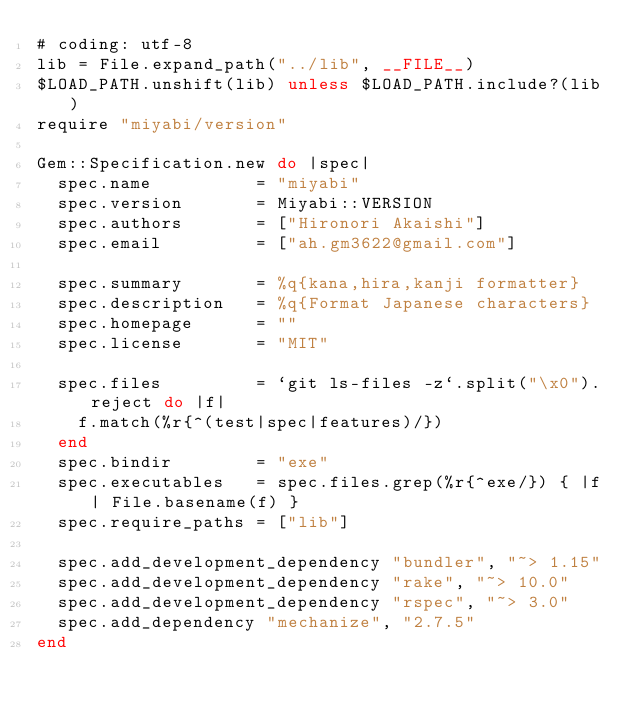<code> <loc_0><loc_0><loc_500><loc_500><_Ruby_># coding: utf-8
lib = File.expand_path("../lib", __FILE__)
$LOAD_PATH.unshift(lib) unless $LOAD_PATH.include?(lib)
require "miyabi/version"

Gem::Specification.new do |spec|
  spec.name          = "miyabi"
  spec.version       = Miyabi::VERSION
  spec.authors       = ["Hironori Akaishi"]
  spec.email         = ["ah.gm3622@gmail.com"]

  spec.summary       = %q{kana,hira,kanji formatter}
  spec.description   = %q{Format Japanese characters}
  spec.homepage      = ""
  spec.license       = "MIT"

  spec.files         = `git ls-files -z`.split("\x0").reject do |f|
    f.match(%r{^(test|spec|features)/})
  end
  spec.bindir        = "exe"
  spec.executables   = spec.files.grep(%r{^exe/}) { |f| File.basename(f) }
  spec.require_paths = ["lib"]

  spec.add_development_dependency "bundler", "~> 1.15"
  spec.add_development_dependency "rake", "~> 10.0"
  spec.add_development_dependency "rspec", "~> 3.0"
  spec.add_dependency "mechanize", "2.7.5"
end
</code> 